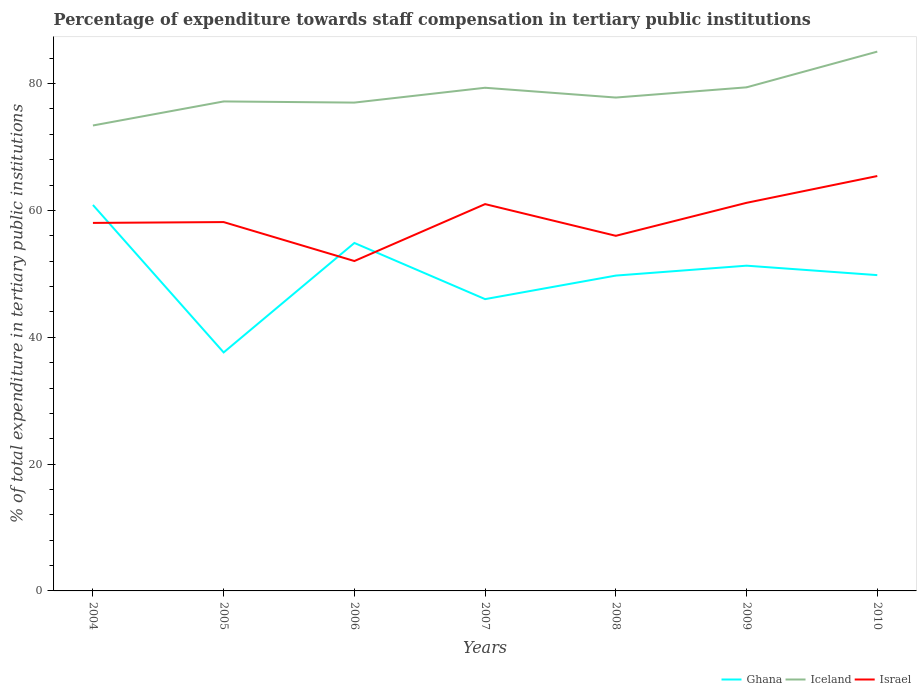Across all years, what is the maximum percentage of expenditure towards staff compensation in Iceland?
Offer a very short reply. 73.4. In which year was the percentage of expenditure towards staff compensation in Ghana maximum?
Give a very brief answer. 2005. What is the total percentage of expenditure towards staff compensation in Iceland in the graph?
Make the answer very short. -11.65. What is the difference between the highest and the second highest percentage of expenditure towards staff compensation in Israel?
Provide a succinct answer. 13.4. What is the difference between the highest and the lowest percentage of expenditure towards staff compensation in Israel?
Your answer should be very brief. 3. How many lines are there?
Give a very brief answer. 3. Are the values on the major ticks of Y-axis written in scientific E-notation?
Provide a succinct answer. No. Does the graph contain grids?
Provide a short and direct response. No. How are the legend labels stacked?
Offer a very short reply. Horizontal. What is the title of the graph?
Ensure brevity in your answer.  Percentage of expenditure towards staff compensation in tertiary public institutions. Does "Spain" appear as one of the legend labels in the graph?
Make the answer very short. No. What is the label or title of the X-axis?
Offer a very short reply. Years. What is the label or title of the Y-axis?
Your answer should be compact. % of total expenditure in tertiary public institutions. What is the % of total expenditure in tertiary public institutions of Ghana in 2004?
Offer a terse response. 60.86. What is the % of total expenditure in tertiary public institutions of Iceland in 2004?
Keep it short and to the point. 73.4. What is the % of total expenditure in tertiary public institutions of Israel in 2004?
Provide a short and direct response. 58.04. What is the % of total expenditure in tertiary public institutions of Ghana in 2005?
Your response must be concise. 37.61. What is the % of total expenditure in tertiary public institutions in Iceland in 2005?
Make the answer very short. 77.19. What is the % of total expenditure in tertiary public institutions of Israel in 2005?
Your answer should be compact. 58.17. What is the % of total expenditure in tertiary public institutions of Ghana in 2006?
Your response must be concise. 54.87. What is the % of total expenditure in tertiary public institutions in Iceland in 2006?
Provide a short and direct response. 77.01. What is the % of total expenditure in tertiary public institutions of Israel in 2006?
Offer a very short reply. 52.02. What is the % of total expenditure in tertiary public institutions of Ghana in 2007?
Keep it short and to the point. 46.02. What is the % of total expenditure in tertiary public institutions of Iceland in 2007?
Offer a very short reply. 79.35. What is the % of total expenditure in tertiary public institutions of Ghana in 2008?
Your answer should be compact. 49.73. What is the % of total expenditure in tertiary public institutions in Iceland in 2008?
Your answer should be very brief. 77.8. What is the % of total expenditure in tertiary public institutions of Ghana in 2009?
Keep it short and to the point. 51.29. What is the % of total expenditure in tertiary public institutions of Iceland in 2009?
Your answer should be compact. 79.42. What is the % of total expenditure in tertiary public institutions of Israel in 2009?
Give a very brief answer. 61.2. What is the % of total expenditure in tertiary public institutions in Ghana in 2010?
Provide a short and direct response. 49.8. What is the % of total expenditure in tertiary public institutions in Iceland in 2010?
Give a very brief answer. 85.05. What is the % of total expenditure in tertiary public institutions in Israel in 2010?
Provide a succinct answer. 65.43. Across all years, what is the maximum % of total expenditure in tertiary public institutions in Ghana?
Your answer should be very brief. 60.86. Across all years, what is the maximum % of total expenditure in tertiary public institutions of Iceland?
Your response must be concise. 85.05. Across all years, what is the maximum % of total expenditure in tertiary public institutions in Israel?
Your response must be concise. 65.43. Across all years, what is the minimum % of total expenditure in tertiary public institutions of Ghana?
Give a very brief answer. 37.61. Across all years, what is the minimum % of total expenditure in tertiary public institutions in Iceland?
Provide a succinct answer. 73.4. Across all years, what is the minimum % of total expenditure in tertiary public institutions in Israel?
Ensure brevity in your answer.  52.02. What is the total % of total expenditure in tertiary public institutions of Ghana in the graph?
Offer a very short reply. 350.19. What is the total % of total expenditure in tertiary public institutions in Iceland in the graph?
Your answer should be very brief. 549.22. What is the total % of total expenditure in tertiary public institutions in Israel in the graph?
Your response must be concise. 411.86. What is the difference between the % of total expenditure in tertiary public institutions in Ghana in 2004 and that in 2005?
Give a very brief answer. 23.25. What is the difference between the % of total expenditure in tertiary public institutions in Iceland in 2004 and that in 2005?
Ensure brevity in your answer.  -3.79. What is the difference between the % of total expenditure in tertiary public institutions in Israel in 2004 and that in 2005?
Ensure brevity in your answer.  -0.13. What is the difference between the % of total expenditure in tertiary public institutions in Ghana in 2004 and that in 2006?
Provide a short and direct response. 5.99. What is the difference between the % of total expenditure in tertiary public institutions of Iceland in 2004 and that in 2006?
Offer a terse response. -3.61. What is the difference between the % of total expenditure in tertiary public institutions in Israel in 2004 and that in 2006?
Provide a short and direct response. 6.01. What is the difference between the % of total expenditure in tertiary public institutions of Ghana in 2004 and that in 2007?
Ensure brevity in your answer.  14.85. What is the difference between the % of total expenditure in tertiary public institutions of Iceland in 2004 and that in 2007?
Your answer should be very brief. -5.95. What is the difference between the % of total expenditure in tertiary public institutions in Israel in 2004 and that in 2007?
Your response must be concise. -2.96. What is the difference between the % of total expenditure in tertiary public institutions in Ghana in 2004 and that in 2008?
Provide a succinct answer. 11.14. What is the difference between the % of total expenditure in tertiary public institutions of Iceland in 2004 and that in 2008?
Offer a very short reply. -4.41. What is the difference between the % of total expenditure in tertiary public institutions of Israel in 2004 and that in 2008?
Make the answer very short. 2.04. What is the difference between the % of total expenditure in tertiary public institutions in Ghana in 2004 and that in 2009?
Give a very brief answer. 9.57. What is the difference between the % of total expenditure in tertiary public institutions of Iceland in 2004 and that in 2009?
Give a very brief answer. -6.02. What is the difference between the % of total expenditure in tertiary public institutions of Israel in 2004 and that in 2009?
Offer a terse response. -3.17. What is the difference between the % of total expenditure in tertiary public institutions of Ghana in 2004 and that in 2010?
Offer a terse response. 11.06. What is the difference between the % of total expenditure in tertiary public institutions in Iceland in 2004 and that in 2010?
Provide a short and direct response. -11.65. What is the difference between the % of total expenditure in tertiary public institutions of Israel in 2004 and that in 2010?
Keep it short and to the point. -7.39. What is the difference between the % of total expenditure in tertiary public institutions in Ghana in 2005 and that in 2006?
Your answer should be compact. -17.26. What is the difference between the % of total expenditure in tertiary public institutions in Iceland in 2005 and that in 2006?
Provide a short and direct response. 0.18. What is the difference between the % of total expenditure in tertiary public institutions of Israel in 2005 and that in 2006?
Offer a terse response. 6.14. What is the difference between the % of total expenditure in tertiary public institutions in Ghana in 2005 and that in 2007?
Ensure brevity in your answer.  -8.4. What is the difference between the % of total expenditure in tertiary public institutions of Iceland in 2005 and that in 2007?
Provide a succinct answer. -2.16. What is the difference between the % of total expenditure in tertiary public institutions of Israel in 2005 and that in 2007?
Make the answer very short. -2.83. What is the difference between the % of total expenditure in tertiary public institutions in Ghana in 2005 and that in 2008?
Offer a terse response. -12.12. What is the difference between the % of total expenditure in tertiary public institutions of Iceland in 2005 and that in 2008?
Offer a terse response. -0.61. What is the difference between the % of total expenditure in tertiary public institutions in Israel in 2005 and that in 2008?
Ensure brevity in your answer.  2.17. What is the difference between the % of total expenditure in tertiary public institutions of Ghana in 2005 and that in 2009?
Your response must be concise. -13.68. What is the difference between the % of total expenditure in tertiary public institutions in Iceland in 2005 and that in 2009?
Make the answer very short. -2.22. What is the difference between the % of total expenditure in tertiary public institutions of Israel in 2005 and that in 2009?
Offer a terse response. -3.04. What is the difference between the % of total expenditure in tertiary public institutions in Ghana in 2005 and that in 2010?
Make the answer very short. -12.19. What is the difference between the % of total expenditure in tertiary public institutions in Iceland in 2005 and that in 2010?
Make the answer very short. -7.86. What is the difference between the % of total expenditure in tertiary public institutions in Israel in 2005 and that in 2010?
Offer a very short reply. -7.26. What is the difference between the % of total expenditure in tertiary public institutions of Ghana in 2006 and that in 2007?
Provide a short and direct response. 8.86. What is the difference between the % of total expenditure in tertiary public institutions of Iceland in 2006 and that in 2007?
Your answer should be compact. -2.34. What is the difference between the % of total expenditure in tertiary public institutions of Israel in 2006 and that in 2007?
Make the answer very short. -8.98. What is the difference between the % of total expenditure in tertiary public institutions in Ghana in 2006 and that in 2008?
Offer a terse response. 5.14. What is the difference between the % of total expenditure in tertiary public institutions in Iceland in 2006 and that in 2008?
Your answer should be compact. -0.79. What is the difference between the % of total expenditure in tertiary public institutions in Israel in 2006 and that in 2008?
Your response must be concise. -3.98. What is the difference between the % of total expenditure in tertiary public institutions in Ghana in 2006 and that in 2009?
Make the answer very short. 3.58. What is the difference between the % of total expenditure in tertiary public institutions in Iceland in 2006 and that in 2009?
Make the answer very short. -2.41. What is the difference between the % of total expenditure in tertiary public institutions of Israel in 2006 and that in 2009?
Your response must be concise. -9.18. What is the difference between the % of total expenditure in tertiary public institutions of Ghana in 2006 and that in 2010?
Your response must be concise. 5.07. What is the difference between the % of total expenditure in tertiary public institutions in Iceland in 2006 and that in 2010?
Give a very brief answer. -8.04. What is the difference between the % of total expenditure in tertiary public institutions of Israel in 2006 and that in 2010?
Provide a succinct answer. -13.4. What is the difference between the % of total expenditure in tertiary public institutions in Ghana in 2007 and that in 2008?
Your response must be concise. -3.71. What is the difference between the % of total expenditure in tertiary public institutions in Iceland in 2007 and that in 2008?
Offer a terse response. 1.54. What is the difference between the % of total expenditure in tertiary public institutions of Ghana in 2007 and that in 2009?
Your answer should be compact. -5.27. What is the difference between the % of total expenditure in tertiary public institutions in Iceland in 2007 and that in 2009?
Your answer should be very brief. -0.07. What is the difference between the % of total expenditure in tertiary public institutions of Israel in 2007 and that in 2009?
Ensure brevity in your answer.  -0.2. What is the difference between the % of total expenditure in tertiary public institutions of Ghana in 2007 and that in 2010?
Keep it short and to the point. -3.79. What is the difference between the % of total expenditure in tertiary public institutions in Iceland in 2007 and that in 2010?
Provide a short and direct response. -5.7. What is the difference between the % of total expenditure in tertiary public institutions of Israel in 2007 and that in 2010?
Offer a terse response. -4.43. What is the difference between the % of total expenditure in tertiary public institutions in Ghana in 2008 and that in 2009?
Give a very brief answer. -1.56. What is the difference between the % of total expenditure in tertiary public institutions of Iceland in 2008 and that in 2009?
Your response must be concise. -1.61. What is the difference between the % of total expenditure in tertiary public institutions of Israel in 2008 and that in 2009?
Your response must be concise. -5.2. What is the difference between the % of total expenditure in tertiary public institutions of Ghana in 2008 and that in 2010?
Give a very brief answer. -0.07. What is the difference between the % of total expenditure in tertiary public institutions in Iceland in 2008 and that in 2010?
Your answer should be compact. -7.24. What is the difference between the % of total expenditure in tertiary public institutions of Israel in 2008 and that in 2010?
Provide a short and direct response. -9.43. What is the difference between the % of total expenditure in tertiary public institutions in Ghana in 2009 and that in 2010?
Offer a very short reply. 1.49. What is the difference between the % of total expenditure in tertiary public institutions in Iceland in 2009 and that in 2010?
Make the answer very short. -5.63. What is the difference between the % of total expenditure in tertiary public institutions in Israel in 2009 and that in 2010?
Give a very brief answer. -4.22. What is the difference between the % of total expenditure in tertiary public institutions of Ghana in 2004 and the % of total expenditure in tertiary public institutions of Iceland in 2005?
Offer a very short reply. -16.33. What is the difference between the % of total expenditure in tertiary public institutions in Ghana in 2004 and the % of total expenditure in tertiary public institutions in Israel in 2005?
Your answer should be compact. 2.7. What is the difference between the % of total expenditure in tertiary public institutions in Iceland in 2004 and the % of total expenditure in tertiary public institutions in Israel in 2005?
Ensure brevity in your answer.  15.23. What is the difference between the % of total expenditure in tertiary public institutions of Ghana in 2004 and the % of total expenditure in tertiary public institutions of Iceland in 2006?
Give a very brief answer. -16.15. What is the difference between the % of total expenditure in tertiary public institutions of Ghana in 2004 and the % of total expenditure in tertiary public institutions of Israel in 2006?
Your answer should be very brief. 8.84. What is the difference between the % of total expenditure in tertiary public institutions in Iceland in 2004 and the % of total expenditure in tertiary public institutions in Israel in 2006?
Offer a very short reply. 21.37. What is the difference between the % of total expenditure in tertiary public institutions of Ghana in 2004 and the % of total expenditure in tertiary public institutions of Iceland in 2007?
Keep it short and to the point. -18.48. What is the difference between the % of total expenditure in tertiary public institutions in Ghana in 2004 and the % of total expenditure in tertiary public institutions in Israel in 2007?
Your answer should be compact. -0.14. What is the difference between the % of total expenditure in tertiary public institutions in Iceland in 2004 and the % of total expenditure in tertiary public institutions in Israel in 2007?
Make the answer very short. 12.4. What is the difference between the % of total expenditure in tertiary public institutions in Ghana in 2004 and the % of total expenditure in tertiary public institutions in Iceland in 2008?
Offer a terse response. -16.94. What is the difference between the % of total expenditure in tertiary public institutions of Ghana in 2004 and the % of total expenditure in tertiary public institutions of Israel in 2008?
Your answer should be compact. 4.86. What is the difference between the % of total expenditure in tertiary public institutions in Iceland in 2004 and the % of total expenditure in tertiary public institutions in Israel in 2008?
Ensure brevity in your answer.  17.4. What is the difference between the % of total expenditure in tertiary public institutions in Ghana in 2004 and the % of total expenditure in tertiary public institutions in Iceland in 2009?
Provide a short and direct response. -18.55. What is the difference between the % of total expenditure in tertiary public institutions in Ghana in 2004 and the % of total expenditure in tertiary public institutions in Israel in 2009?
Give a very brief answer. -0.34. What is the difference between the % of total expenditure in tertiary public institutions in Iceland in 2004 and the % of total expenditure in tertiary public institutions in Israel in 2009?
Ensure brevity in your answer.  12.19. What is the difference between the % of total expenditure in tertiary public institutions in Ghana in 2004 and the % of total expenditure in tertiary public institutions in Iceland in 2010?
Ensure brevity in your answer.  -24.18. What is the difference between the % of total expenditure in tertiary public institutions in Ghana in 2004 and the % of total expenditure in tertiary public institutions in Israel in 2010?
Ensure brevity in your answer.  -4.56. What is the difference between the % of total expenditure in tertiary public institutions of Iceland in 2004 and the % of total expenditure in tertiary public institutions of Israel in 2010?
Your answer should be compact. 7.97. What is the difference between the % of total expenditure in tertiary public institutions of Ghana in 2005 and the % of total expenditure in tertiary public institutions of Iceland in 2006?
Your answer should be compact. -39.4. What is the difference between the % of total expenditure in tertiary public institutions of Ghana in 2005 and the % of total expenditure in tertiary public institutions of Israel in 2006?
Offer a terse response. -14.41. What is the difference between the % of total expenditure in tertiary public institutions of Iceland in 2005 and the % of total expenditure in tertiary public institutions of Israel in 2006?
Make the answer very short. 25.17. What is the difference between the % of total expenditure in tertiary public institutions of Ghana in 2005 and the % of total expenditure in tertiary public institutions of Iceland in 2007?
Offer a very short reply. -41.74. What is the difference between the % of total expenditure in tertiary public institutions of Ghana in 2005 and the % of total expenditure in tertiary public institutions of Israel in 2007?
Offer a very short reply. -23.39. What is the difference between the % of total expenditure in tertiary public institutions in Iceland in 2005 and the % of total expenditure in tertiary public institutions in Israel in 2007?
Give a very brief answer. 16.19. What is the difference between the % of total expenditure in tertiary public institutions of Ghana in 2005 and the % of total expenditure in tertiary public institutions of Iceland in 2008?
Keep it short and to the point. -40.19. What is the difference between the % of total expenditure in tertiary public institutions in Ghana in 2005 and the % of total expenditure in tertiary public institutions in Israel in 2008?
Ensure brevity in your answer.  -18.39. What is the difference between the % of total expenditure in tertiary public institutions in Iceland in 2005 and the % of total expenditure in tertiary public institutions in Israel in 2008?
Make the answer very short. 21.19. What is the difference between the % of total expenditure in tertiary public institutions in Ghana in 2005 and the % of total expenditure in tertiary public institutions in Iceland in 2009?
Give a very brief answer. -41.81. What is the difference between the % of total expenditure in tertiary public institutions of Ghana in 2005 and the % of total expenditure in tertiary public institutions of Israel in 2009?
Make the answer very short. -23.59. What is the difference between the % of total expenditure in tertiary public institutions in Iceland in 2005 and the % of total expenditure in tertiary public institutions in Israel in 2009?
Your answer should be compact. 15.99. What is the difference between the % of total expenditure in tertiary public institutions of Ghana in 2005 and the % of total expenditure in tertiary public institutions of Iceland in 2010?
Keep it short and to the point. -47.44. What is the difference between the % of total expenditure in tertiary public institutions of Ghana in 2005 and the % of total expenditure in tertiary public institutions of Israel in 2010?
Provide a short and direct response. -27.82. What is the difference between the % of total expenditure in tertiary public institutions in Iceland in 2005 and the % of total expenditure in tertiary public institutions in Israel in 2010?
Offer a terse response. 11.76. What is the difference between the % of total expenditure in tertiary public institutions in Ghana in 2006 and the % of total expenditure in tertiary public institutions in Iceland in 2007?
Make the answer very short. -24.48. What is the difference between the % of total expenditure in tertiary public institutions in Ghana in 2006 and the % of total expenditure in tertiary public institutions in Israel in 2007?
Keep it short and to the point. -6.13. What is the difference between the % of total expenditure in tertiary public institutions of Iceland in 2006 and the % of total expenditure in tertiary public institutions of Israel in 2007?
Keep it short and to the point. 16.01. What is the difference between the % of total expenditure in tertiary public institutions of Ghana in 2006 and the % of total expenditure in tertiary public institutions of Iceland in 2008?
Your answer should be very brief. -22.93. What is the difference between the % of total expenditure in tertiary public institutions in Ghana in 2006 and the % of total expenditure in tertiary public institutions in Israel in 2008?
Provide a succinct answer. -1.13. What is the difference between the % of total expenditure in tertiary public institutions in Iceland in 2006 and the % of total expenditure in tertiary public institutions in Israel in 2008?
Your answer should be very brief. 21.01. What is the difference between the % of total expenditure in tertiary public institutions of Ghana in 2006 and the % of total expenditure in tertiary public institutions of Iceland in 2009?
Ensure brevity in your answer.  -24.54. What is the difference between the % of total expenditure in tertiary public institutions of Ghana in 2006 and the % of total expenditure in tertiary public institutions of Israel in 2009?
Make the answer very short. -6.33. What is the difference between the % of total expenditure in tertiary public institutions of Iceland in 2006 and the % of total expenditure in tertiary public institutions of Israel in 2009?
Offer a terse response. 15.81. What is the difference between the % of total expenditure in tertiary public institutions in Ghana in 2006 and the % of total expenditure in tertiary public institutions in Iceland in 2010?
Your response must be concise. -30.18. What is the difference between the % of total expenditure in tertiary public institutions of Ghana in 2006 and the % of total expenditure in tertiary public institutions of Israel in 2010?
Give a very brief answer. -10.55. What is the difference between the % of total expenditure in tertiary public institutions of Iceland in 2006 and the % of total expenditure in tertiary public institutions of Israel in 2010?
Give a very brief answer. 11.58. What is the difference between the % of total expenditure in tertiary public institutions of Ghana in 2007 and the % of total expenditure in tertiary public institutions of Iceland in 2008?
Provide a short and direct response. -31.79. What is the difference between the % of total expenditure in tertiary public institutions in Ghana in 2007 and the % of total expenditure in tertiary public institutions in Israel in 2008?
Ensure brevity in your answer.  -9.98. What is the difference between the % of total expenditure in tertiary public institutions in Iceland in 2007 and the % of total expenditure in tertiary public institutions in Israel in 2008?
Your answer should be compact. 23.35. What is the difference between the % of total expenditure in tertiary public institutions in Ghana in 2007 and the % of total expenditure in tertiary public institutions in Iceland in 2009?
Your answer should be very brief. -33.4. What is the difference between the % of total expenditure in tertiary public institutions of Ghana in 2007 and the % of total expenditure in tertiary public institutions of Israel in 2009?
Your answer should be very brief. -15.19. What is the difference between the % of total expenditure in tertiary public institutions in Iceland in 2007 and the % of total expenditure in tertiary public institutions in Israel in 2009?
Provide a succinct answer. 18.14. What is the difference between the % of total expenditure in tertiary public institutions in Ghana in 2007 and the % of total expenditure in tertiary public institutions in Iceland in 2010?
Your answer should be very brief. -39.03. What is the difference between the % of total expenditure in tertiary public institutions in Ghana in 2007 and the % of total expenditure in tertiary public institutions in Israel in 2010?
Offer a terse response. -19.41. What is the difference between the % of total expenditure in tertiary public institutions in Iceland in 2007 and the % of total expenditure in tertiary public institutions in Israel in 2010?
Keep it short and to the point. 13.92. What is the difference between the % of total expenditure in tertiary public institutions of Ghana in 2008 and the % of total expenditure in tertiary public institutions of Iceland in 2009?
Keep it short and to the point. -29.69. What is the difference between the % of total expenditure in tertiary public institutions in Ghana in 2008 and the % of total expenditure in tertiary public institutions in Israel in 2009?
Offer a very short reply. -11.47. What is the difference between the % of total expenditure in tertiary public institutions of Iceland in 2008 and the % of total expenditure in tertiary public institutions of Israel in 2009?
Give a very brief answer. 16.6. What is the difference between the % of total expenditure in tertiary public institutions in Ghana in 2008 and the % of total expenditure in tertiary public institutions in Iceland in 2010?
Make the answer very short. -35.32. What is the difference between the % of total expenditure in tertiary public institutions of Ghana in 2008 and the % of total expenditure in tertiary public institutions of Israel in 2010?
Ensure brevity in your answer.  -15.7. What is the difference between the % of total expenditure in tertiary public institutions of Iceland in 2008 and the % of total expenditure in tertiary public institutions of Israel in 2010?
Offer a very short reply. 12.38. What is the difference between the % of total expenditure in tertiary public institutions of Ghana in 2009 and the % of total expenditure in tertiary public institutions of Iceland in 2010?
Offer a very short reply. -33.76. What is the difference between the % of total expenditure in tertiary public institutions in Ghana in 2009 and the % of total expenditure in tertiary public institutions in Israel in 2010?
Offer a very short reply. -14.14. What is the difference between the % of total expenditure in tertiary public institutions in Iceland in 2009 and the % of total expenditure in tertiary public institutions in Israel in 2010?
Your answer should be compact. 13.99. What is the average % of total expenditure in tertiary public institutions of Ghana per year?
Your response must be concise. 50.03. What is the average % of total expenditure in tertiary public institutions of Iceland per year?
Offer a very short reply. 78.46. What is the average % of total expenditure in tertiary public institutions in Israel per year?
Keep it short and to the point. 58.84. In the year 2004, what is the difference between the % of total expenditure in tertiary public institutions in Ghana and % of total expenditure in tertiary public institutions in Iceland?
Offer a terse response. -12.53. In the year 2004, what is the difference between the % of total expenditure in tertiary public institutions in Ghana and % of total expenditure in tertiary public institutions in Israel?
Offer a very short reply. 2.83. In the year 2004, what is the difference between the % of total expenditure in tertiary public institutions in Iceland and % of total expenditure in tertiary public institutions in Israel?
Offer a terse response. 15.36. In the year 2005, what is the difference between the % of total expenditure in tertiary public institutions in Ghana and % of total expenditure in tertiary public institutions in Iceland?
Your answer should be compact. -39.58. In the year 2005, what is the difference between the % of total expenditure in tertiary public institutions of Ghana and % of total expenditure in tertiary public institutions of Israel?
Ensure brevity in your answer.  -20.55. In the year 2005, what is the difference between the % of total expenditure in tertiary public institutions of Iceland and % of total expenditure in tertiary public institutions of Israel?
Make the answer very short. 19.03. In the year 2006, what is the difference between the % of total expenditure in tertiary public institutions of Ghana and % of total expenditure in tertiary public institutions of Iceland?
Offer a very short reply. -22.14. In the year 2006, what is the difference between the % of total expenditure in tertiary public institutions in Ghana and % of total expenditure in tertiary public institutions in Israel?
Ensure brevity in your answer.  2.85. In the year 2006, what is the difference between the % of total expenditure in tertiary public institutions of Iceland and % of total expenditure in tertiary public institutions of Israel?
Keep it short and to the point. 24.99. In the year 2007, what is the difference between the % of total expenditure in tertiary public institutions in Ghana and % of total expenditure in tertiary public institutions in Iceland?
Offer a terse response. -33.33. In the year 2007, what is the difference between the % of total expenditure in tertiary public institutions of Ghana and % of total expenditure in tertiary public institutions of Israel?
Keep it short and to the point. -14.98. In the year 2007, what is the difference between the % of total expenditure in tertiary public institutions in Iceland and % of total expenditure in tertiary public institutions in Israel?
Your answer should be very brief. 18.35. In the year 2008, what is the difference between the % of total expenditure in tertiary public institutions of Ghana and % of total expenditure in tertiary public institutions of Iceland?
Your answer should be very brief. -28.07. In the year 2008, what is the difference between the % of total expenditure in tertiary public institutions of Ghana and % of total expenditure in tertiary public institutions of Israel?
Make the answer very short. -6.27. In the year 2008, what is the difference between the % of total expenditure in tertiary public institutions in Iceland and % of total expenditure in tertiary public institutions in Israel?
Make the answer very short. 21.8. In the year 2009, what is the difference between the % of total expenditure in tertiary public institutions in Ghana and % of total expenditure in tertiary public institutions in Iceland?
Give a very brief answer. -28.13. In the year 2009, what is the difference between the % of total expenditure in tertiary public institutions in Ghana and % of total expenditure in tertiary public institutions in Israel?
Your answer should be compact. -9.91. In the year 2009, what is the difference between the % of total expenditure in tertiary public institutions in Iceland and % of total expenditure in tertiary public institutions in Israel?
Provide a succinct answer. 18.21. In the year 2010, what is the difference between the % of total expenditure in tertiary public institutions of Ghana and % of total expenditure in tertiary public institutions of Iceland?
Your response must be concise. -35.25. In the year 2010, what is the difference between the % of total expenditure in tertiary public institutions in Ghana and % of total expenditure in tertiary public institutions in Israel?
Keep it short and to the point. -15.63. In the year 2010, what is the difference between the % of total expenditure in tertiary public institutions in Iceland and % of total expenditure in tertiary public institutions in Israel?
Give a very brief answer. 19.62. What is the ratio of the % of total expenditure in tertiary public institutions in Ghana in 2004 to that in 2005?
Keep it short and to the point. 1.62. What is the ratio of the % of total expenditure in tertiary public institutions of Iceland in 2004 to that in 2005?
Give a very brief answer. 0.95. What is the ratio of the % of total expenditure in tertiary public institutions in Israel in 2004 to that in 2005?
Your response must be concise. 1. What is the ratio of the % of total expenditure in tertiary public institutions in Ghana in 2004 to that in 2006?
Provide a short and direct response. 1.11. What is the ratio of the % of total expenditure in tertiary public institutions of Iceland in 2004 to that in 2006?
Keep it short and to the point. 0.95. What is the ratio of the % of total expenditure in tertiary public institutions of Israel in 2004 to that in 2006?
Your answer should be very brief. 1.12. What is the ratio of the % of total expenditure in tertiary public institutions in Ghana in 2004 to that in 2007?
Provide a succinct answer. 1.32. What is the ratio of the % of total expenditure in tertiary public institutions of Iceland in 2004 to that in 2007?
Your response must be concise. 0.93. What is the ratio of the % of total expenditure in tertiary public institutions of Israel in 2004 to that in 2007?
Make the answer very short. 0.95. What is the ratio of the % of total expenditure in tertiary public institutions of Ghana in 2004 to that in 2008?
Offer a terse response. 1.22. What is the ratio of the % of total expenditure in tertiary public institutions in Iceland in 2004 to that in 2008?
Ensure brevity in your answer.  0.94. What is the ratio of the % of total expenditure in tertiary public institutions in Israel in 2004 to that in 2008?
Provide a short and direct response. 1.04. What is the ratio of the % of total expenditure in tertiary public institutions of Ghana in 2004 to that in 2009?
Your answer should be very brief. 1.19. What is the ratio of the % of total expenditure in tertiary public institutions in Iceland in 2004 to that in 2009?
Offer a terse response. 0.92. What is the ratio of the % of total expenditure in tertiary public institutions in Israel in 2004 to that in 2009?
Offer a terse response. 0.95. What is the ratio of the % of total expenditure in tertiary public institutions in Ghana in 2004 to that in 2010?
Ensure brevity in your answer.  1.22. What is the ratio of the % of total expenditure in tertiary public institutions of Iceland in 2004 to that in 2010?
Keep it short and to the point. 0.86. What is the ratio of the % of total expenditure in tertiary public institutions of Israel in 2004 to that in 2010?
Keep it short and to the point. 0.89. What is the ratio of the % of total expenditure in tertiary public institutions in Ghana in 2005 to that in 2006?
Make the answer very short. 0.69. What is the ratio of the % of total expenditure in tertiary public institutions of Israel in 2005 to that in 2006?
Your answer should be very brief. 1.12. What is the ratio of the % of total expenditure in tertiary public institutions in Ghana in 2005 to that in 2007?
Offer a terse response. 0.82. What is the ratio of the % of total expenditure in tertiary public institutions in Iceland in 2005 to that in 2007?
Make the answer very short. 0.97. What is the ratio of the % of total expenditure in tertiary public institutions in Israel in 2005 to that in 2007?
Ensure brevity in your answer.  0.95. What is the ratio of the % of total expenditure in tertiary public institutions of Ghana in 2005 to that in 2008?
Offer a very short reply. 0.76. What is the ratio of the % of total expenditure in tertiary public institutions in Israel in 2005 to that in 2008?
Provide a short and direct response. 1.04. What is the ratio of the % of total expenditure in tertiary public institutions in Ghana in 2005 to that in 2009?
Give a very brief answer. 0.73. What is the ratio of the % of total expenditure in tertiary public institutions of Iceland in 2005 to that in 2009?
Keep it short and to the point. 0.97. What is the ratio of the % of total expenditure in tertiary public institutions of Israel in 2005 to that in 2009?
Ensure brevity in your answer.  0.95. What is the ratio of the % of total expenditure in tertiary public institutions of Ghana in 2005 to that in 2010?
Make the answer very short. 0.76. What is the ratio of the % of total expenditure in tertiary public institutions in Iceland in 2005 to that in 2010?
Give a very brief answer. 0.91. What is the ratio of the % of total expenditure in tertiary public institutions of Israel in 2005 to that in 2010?
Your answer should be very brief. 0.89. What is the ratio of the % of total expenditure in tertiary public institutions in Ghana in 2006 to that in 2007?
Ensure brevity in your answer.  1.19. What is the ratio of the % of total expenditure in tertiary public institutions in Iceland in 2006 to that in 2007?
Offer a terse response. 0.97. What is the ratio of the % of total expenditure in tertiary public institutions of Israel in 2006 to that in 2007?
Keep it short and to the point. 0.85. What is the ratio of the % of total expenditure in tertiary public institutions of Ghana in 2006 to that in 2008?
Your answer should be compact. 1.1. What is the ratio of the % of total expenditure in tertiary public institutions of Iceland in 2006 to that in 2008?
Provide a succinct answer. 0.99. What is the ratio of the % of total expenditure in tertiary public institutions in Israel in 2006 to that in 2008?
Offer a terse response. 0.93. What is the ratio of the % of total expenditure in tertiary public institutions of Ghana in 2006 to that in 2009?
Make the answer very short. 1.07. What is the ratio of the % of total expenditure in tertiary public institutions in Iceland in 2006 to that in 2009?
Make the answer very short. 0.97. What is the ratio of the % of total expenditure in tertiary public institutions of Israel in 2006 to that in 2009?
Provide a succinct answer. 0.85. What is the ratio of the % of total expenditure in tertiary public institutions in Ghana in 2006 to that in 2010?
Give a very brief answer. 1.1. What is the ratio of the % of total expenditure in tertiary public institutions in Iceland in 2006 to that in 2010?
Ensure brevity in your answer.  0.91. What is the ratio of the % of total expenditure in tertiary public institutions of Israel in 2006 to that in 2010?
Your answer should be compact. 0.8. What is the ratio of the % of total expenditure in tertiary public institutions of Ghana in 2007 to that in 2008?
Make the answer very short. 0.93. What is the ratio of the % of total expenditure in tertiary public institutions in Iceland in 2007 to that in 2008?
Give a very brief answer. 1.02. What is the ratio of the % of total expenditure in tertiary public institutions in Israel in 2007 to that in 2008?
Provide a succinct answer. 1.09. What is the ratio of the % of total expenditure in tertiary public institutions of Ghana in 2007 to that in 2009?
Your answer should be compact. 0.9. What is the ratio of the % of total expenditure in tertiary public institutions in Israel in 2007 to that in 2009?
Ensure brevity in your answer.  1. What is the ratio of the % of total expenditure in tertiary public institutions of Ghana in 2007 to that in 2010?
Make the answer very short. 0.92. What is the ratio of the % of total expenditure in tertiary public institutions in Iceland in 2007 to that in 2010?
Ensure brevity in your answer.  0.93. What is the ratio of the % of total expenditure in tertiary public institutions of Israel in 2007 to that in 2010?
Your answer should be very brief. 0.93. What is the ratio of the % of total expenditure in tertiary public institutions of Ghana in 2008 to that in 2009?
Provide a short and direct response. 0.97. What is the ratio of the % of total expenditure in tertiary public institutions of Iceland in 2008 to that in 2009?
Give a very brief answer. 0.98. What is the ratio of the % of total expenditure in tertiary public institutions in Israel in 2008 to that in 2009?
Your response must be concise. 0.92. What is the ratio of the % of total expenditure in tertiary public institutions in Iceland in 2008 to that in 2010?
Offer a terse response. 0.91. What is the ratio of the % of total expenditure in tertiary public institutions of Israel in 2008 to that in 2010?
Your answer should be very brief. 0.86. What is the ratio of the % of total expenditure in tertiary public institutions in Ghana in 2009 to that in 2010?
Your answer should be compact. 1.03. What is the ratio of the % of total expenditure in tertiary public institutions in Iceland in 2009 to that in 2010?
Provide a short and direct response. 0.93. What is the ratio of the % of total expenditure in tertiary public institutions in Israel in 2009 to that in 2010?
Ensure brevity in your answer.  0.94. What is the difference between the highest and the second highest % of total expenditure in tertiary public institutions of Ghana?
Offer a terse response. 5.99. What is the difference between the highest and the second highest % of total expenditure in tertiary public institutions of Iceland?
Offer a terse response. 5.63. What is the difference between the highest and the second highest % of total expenditure in tertiary public institutions in Israel?
Your response must be concise. 4.22. What is the difference between the highest and the lowest % of total expenditure in tertiary public institutions of Ghana?
Provide a succinct answer. 23.25. What is the difference between the highest and the lowest % of total expenditure in tertiary public institutions of Iceland?
Keep it short and to the point. 11.65. What is the difference between the highest and the lowest % of total expenditure in tertiary public institutions in Israel?
Provide a succinct answer. 13.4. 